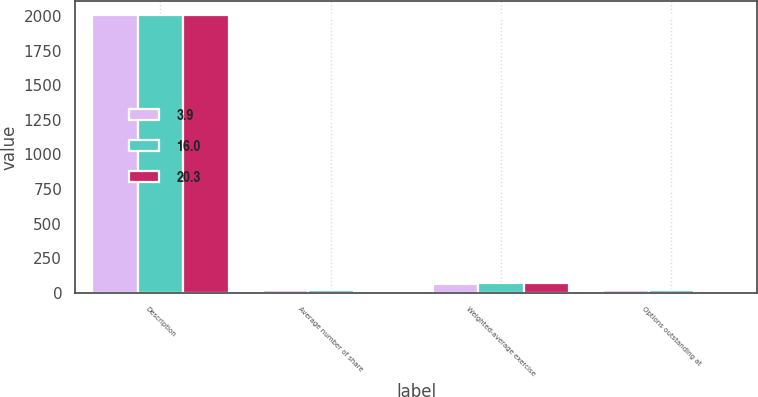<chart> <loc_0><loc_0><loc_500><loc_500><stacked_bar_chart><ecel><fcel>Description<fcel>Average number of share<fcel>Weighted-average exercise<fcel>Options outstanding at<nl><fcel>3.9<fcel>2009<fcel>21.8<fcel>64.12<fcel>20.3<nl><fcel>16<fcel>2008<fcel>15.6<fcel>66.31<fcel>16<nl><fcel>20.3<fcel>2007<fcel>2.8<fcel>72<fcel>3.9<nl></chart> 